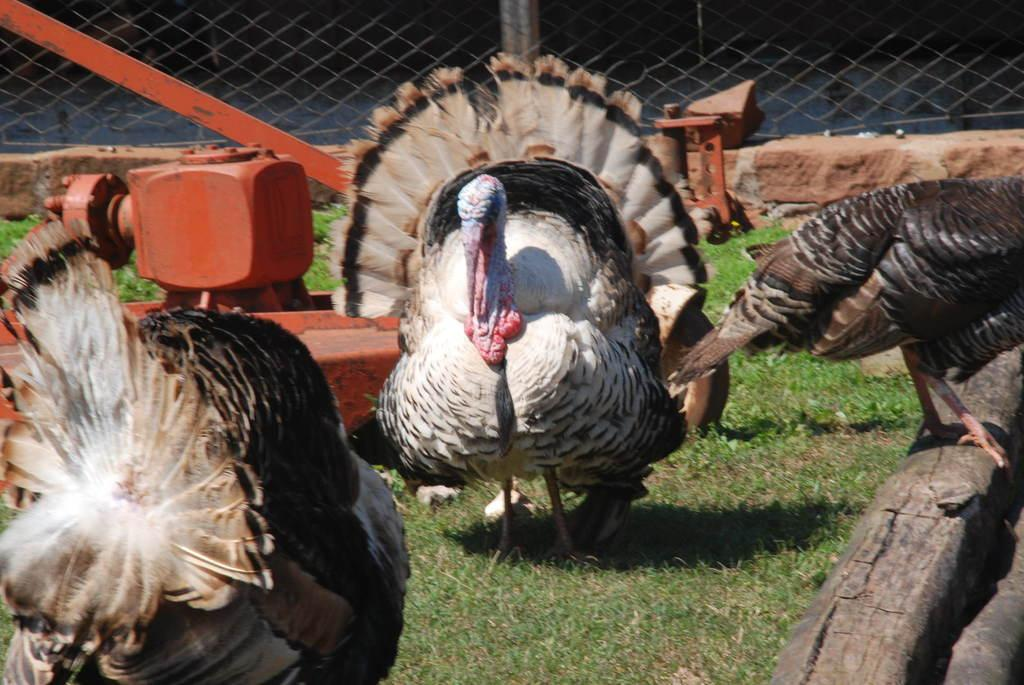What animals can be seen in the image? There are turkeys in the image. What type of machine is present in the image? There is an orange color machine in the image. What type of vegetation is present in the image? Grass is present in the image, and bark is also visible. What architectural feature can be seen in the background of the image? There is a fence in the background of the image. What year is depicted in the image? The image does not depict a specific year; it is a photograph of the present moment. Are there any dinosaurs visible in the image? No, there are no dinosaurs present in the image. 